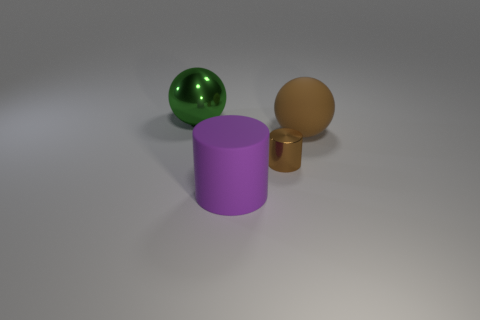Add 2 red blocks. How many objects exist? 6 Add 2 large purple rubber objects. How many large purple rubber objects are left? 3 Add 4 brown cylinders. How many brown cylinders exist? 5 Subtract 0 blue balls. How many objects are left? 4 Subtract all purple cylinders. Subtract all small red rubber things. How many objects are left? 3 